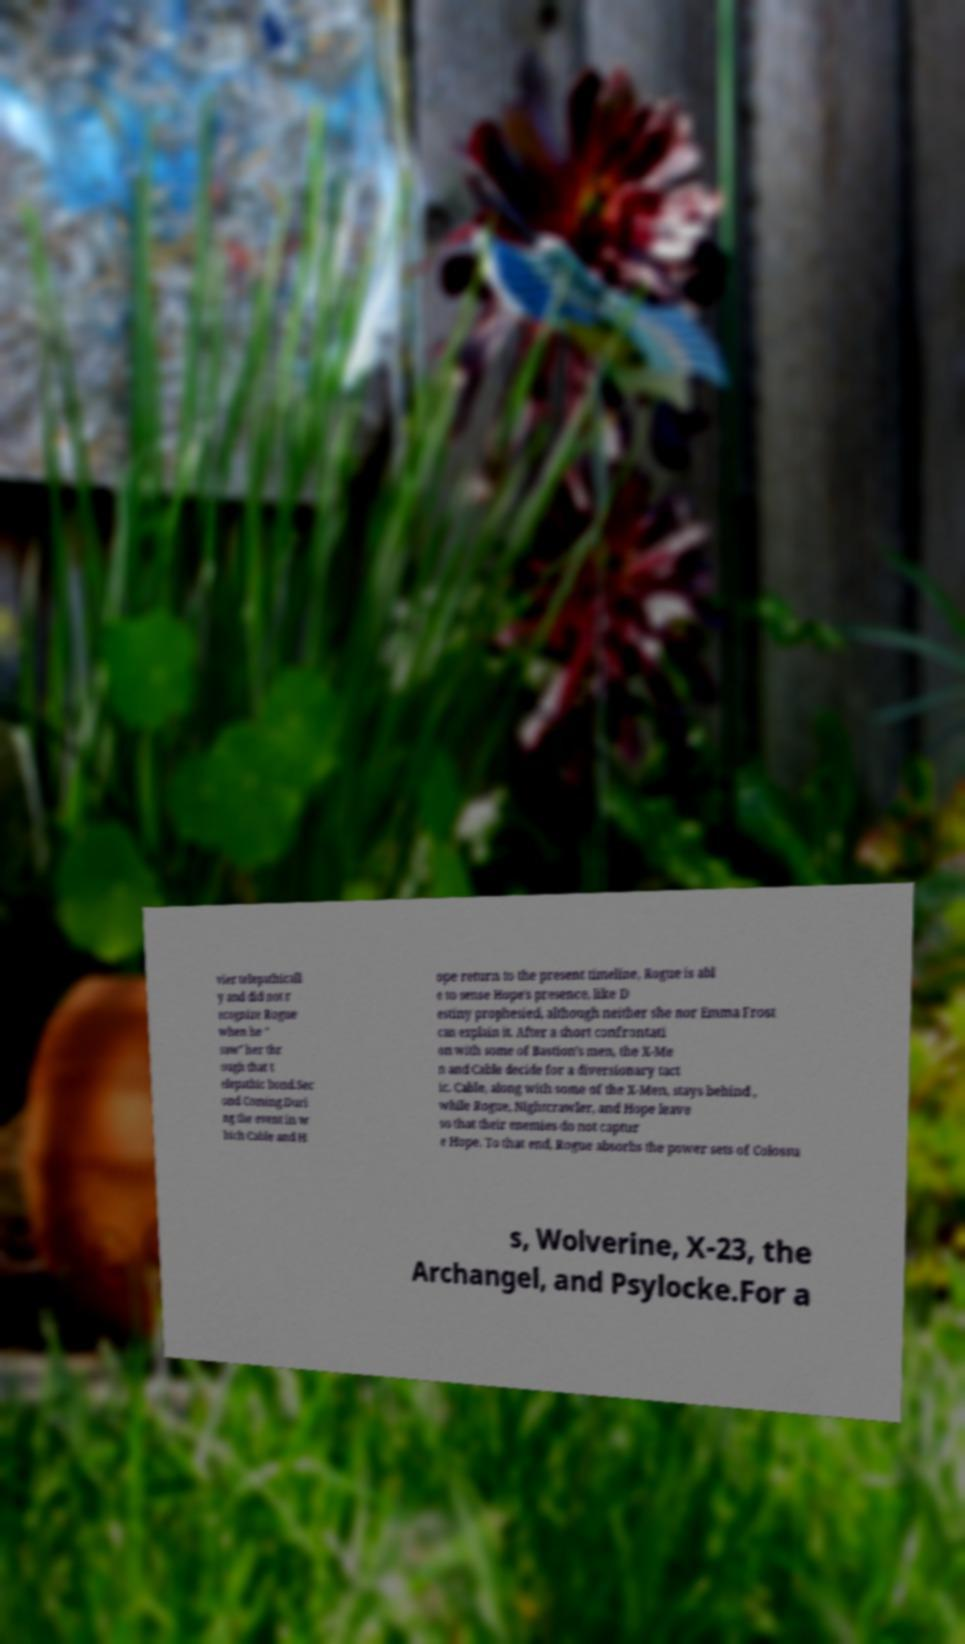I need the written content from this picture converted into text. Can you do that? vier telepathicall y and did not r ecognize Rogue when he " saw" her thr ough that t elepathic bond.Sec ond Coming.Duri ng the event in w hich Cable and H ope return to the present timeline, Rogue is abl e to sense Hope's presence, like D estiny prophesied, although neither she nor Emma Frost can explain it. After a short confrontati on with some of Bastion's men, the X-Me n and Cable decide for a diversionary tact ic. Cable, along with some of the X-Men, stays behind , while Rogue, Nightcrawler, and Hope leave so that their enemies do not captur e Hope. To that end, Rogue absorbs the power sets of Colossu s, Wolverine, X-23, the Archangel, and Psylocke.For a 